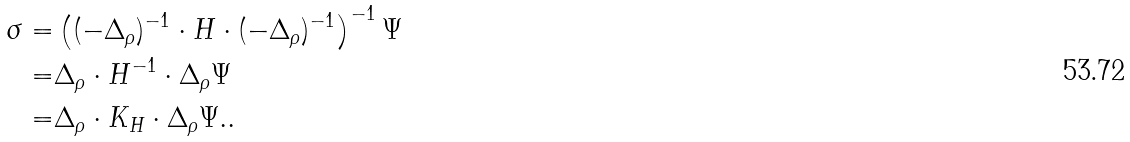<formula> <loc_0><loc_0><loc_500><loc_500>\sigma = & \left ( ( - \Delta _ { \rho } ) ^ { - 1 } \cdot H \cdot ( - \Delta _ { \rho } ) ^ { - 1 } \right ) ^ { - 1 } \Psi \\ = & \Delta _ { \rho } \cdot H ^ { - 1 } \cdot \Delta _ { \rho } \Psi \\ = & \Delta _ { \rho } \cdot K _ { H } \cdot \Delta _ { \rho } \Psi . .</formula> 